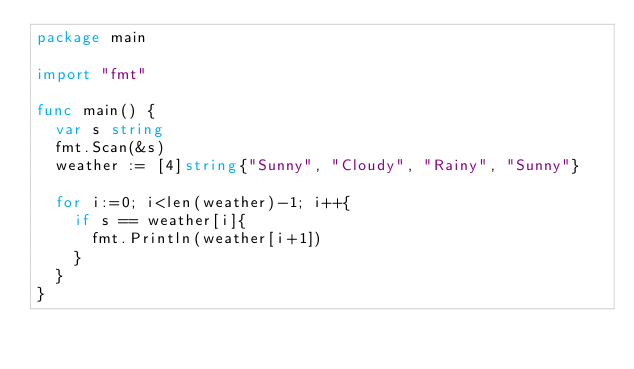<code> <loc_0><loc_0><loc_500><loc_500><_Go_>package main

import "fmt"

func main() {
	var s string
	fmt.Scan(&s)
	weather := [4]string{"Sunny", "Cloudy", "Rainy", "Sunny"}

	for i:=0; i<len(weather)-1; i++{
		if s == weather[i]{
			fmt.Println(weather[i+1])
		}
	}
}</code> 